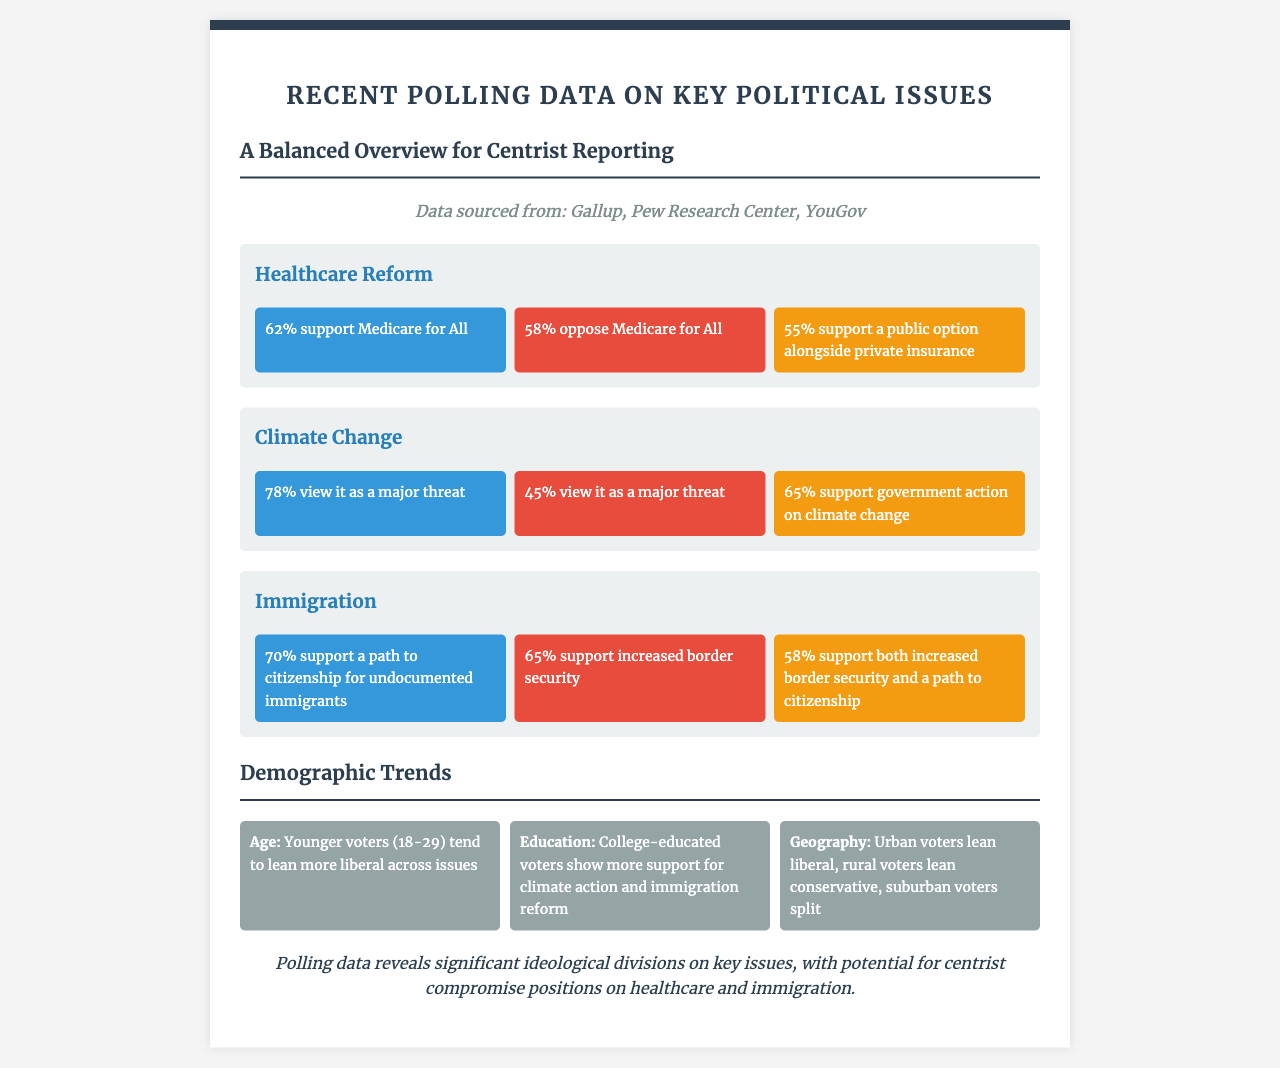What percentage supports Medicare for All? The document states that 62% of liberals support Medicare for All.
Answer: 62% What percentage of conservatives view climate change as a major threat? The document indicates that 45% of conservatives view climate change as a major threat.
Answer: 45% What is the centrist support for a public option in healthcare? It mentions that 55% of centrists support a public option alongside private insurance.
Answer: 55% What demographic tends to lean more liberal? The document notes that younger voters (18-29) tend to lean more liberal across issues.
Answer: Younger voters (18-29) What is the supported compromise position for immigration among centrists? Centrists support both increased border security and a path to citizenship, as stated in the document.
Answer: Both increased border security and a path to citizenship What percentage of liberals support a path to citizenship for undocumented immigrants? The document states that 70% of liberals support a path to citizenship for undocumented immigrants.
Answer: 70% Which polling firms are cited in the document? The document cites Gallup, Pew Research Center, and YouGov as the polling firms.
Answer: Gallup, Pew Research Center, YouGov What percentage of centrists support government action on climate change? The document indicates that 65% of centrists support government action on climate change.
Answer: 65% 